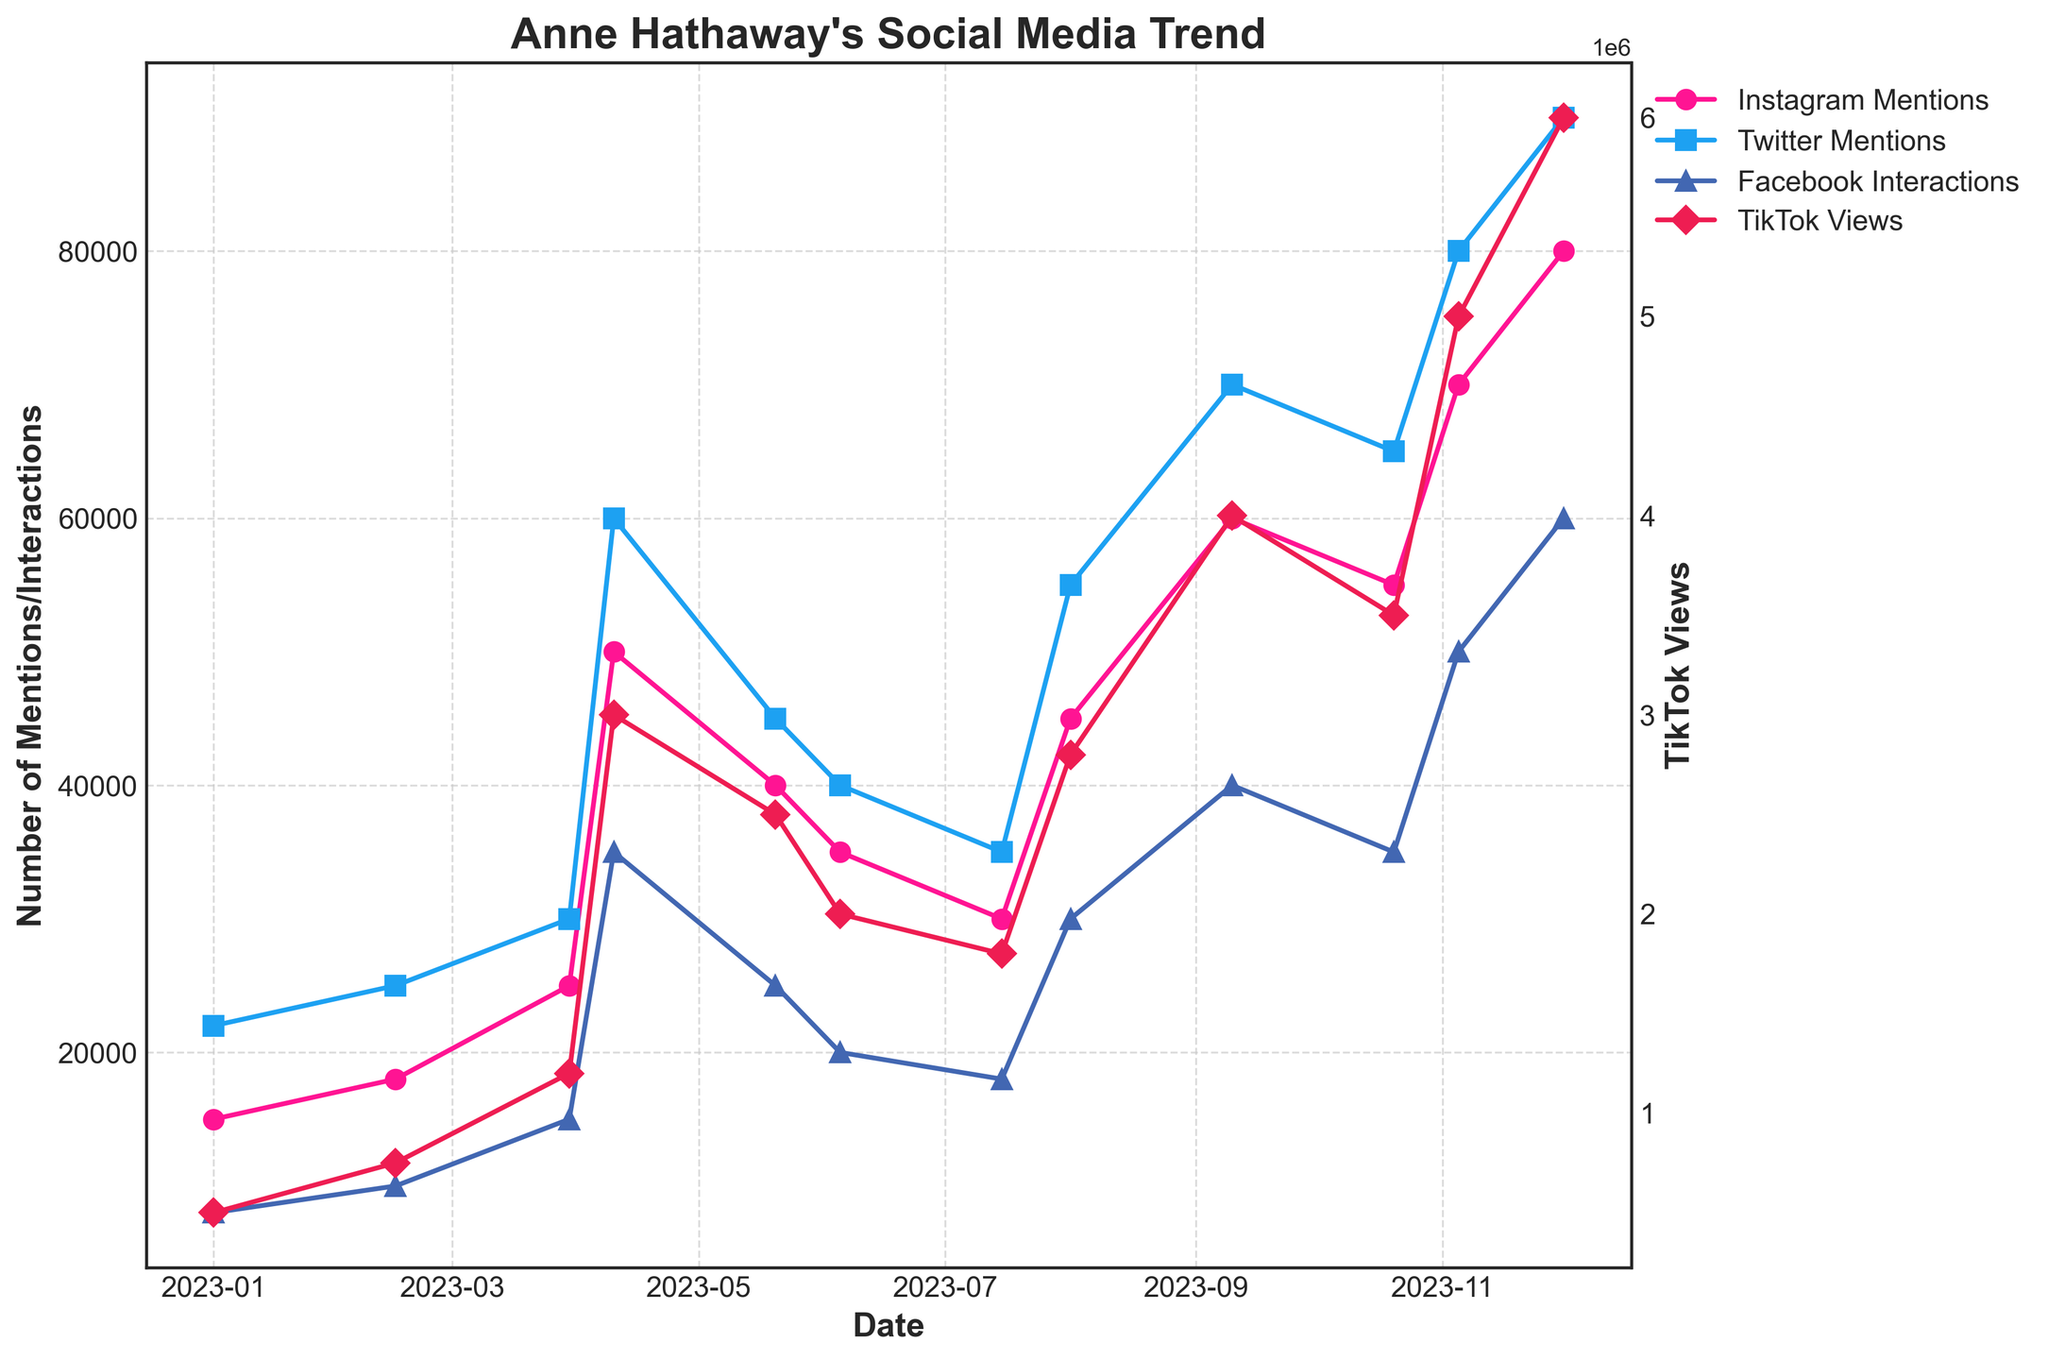Which platform had the highest number of mentions/interactions in December 2023? To find the answer, check the values for December 2023 across all platforms: Instagram, Twitter, TikTok, and Facebook. Instagram has 80,000 mentions, Twitter has 90,000 mentions, TikTok has 6,000,000 views, and Facebook has 60,000 interactions.
Answer: TikTok Between August and November 2023, which platform saw the largest increase in mentions/interactions? Calculate the increase for each platform from August to November. For Instagram: 70,000 - 45,000 = 25,000. For Twitter: 80,000 - 55,000 = 25,000. For TikTok: 5,000,000 - 2,800,000 = 2,200,000. For Facebook: 50,000 - 30,000 = 20,000. TikTok had the largest increase.
Answer: TikTok What is the average number of Facebook interactions from January to June 2023? Sum the Facebook interactions from January to June: 8,000 + 10,000 + 15,000 + 35,000 + 25,000 + 20,000 = 113,000. Divide by the number of months (6): 113,000 / 6 = 18,833.33
Answer: 18,833.33 Which platform had the smallest overall growth from January to December 2023? Calculate the growth for each platform by subtracting the January value from the December value. For Instagram: 80,000 - 15,000 = 65,000. For Twitter: 90,000 - 22,000 = 68,000. For TikTok: 6,000,000 - 500,000 = 5,500,000. For Facebook: 60,000 - 8,000 = 52,000. Facebook had the smallest overall growth.
Answer: Facebook In April 2023, which platform had more mentions/interactions: Instagram or Twitter? Compare the mentions for April 2023: Instagram has 50,000 mentions, while Twitter has 60,000 mentions. Twitter had more.
Answer: Twitter Which month saw a decline in all four platform's mentions/interactions compared to the previous month? Evaluate the values month-by-month to identify any collective decline. From May to June, all platforms decreased: Instagram (40,000 to 35,000), Twitter (45,000 to 40,000), TikTok (2,500,000 to 2,000,000), and Facebook (25,000 to 20,000).
Answer: June How did the number of Instagram mentions change between July and October 2023? Find the difference of Instagram mentions between July and October: 55,000 - 30,000 = 25,000.
Answer: Increased by 25,000 What is the median number of Twitter mentions for the entire year? List the Twitter mentions in ascending order: 22,000, 25,000, 30,000, 35,000, 40,000, 45,000, 55,000, 60,000, 65,000, 70,000, 80,000, 90,000. The median is the average of the 6th and 7th values: (45,000 + 55,000) / 2 = 50,000.
Answer: 50,000 